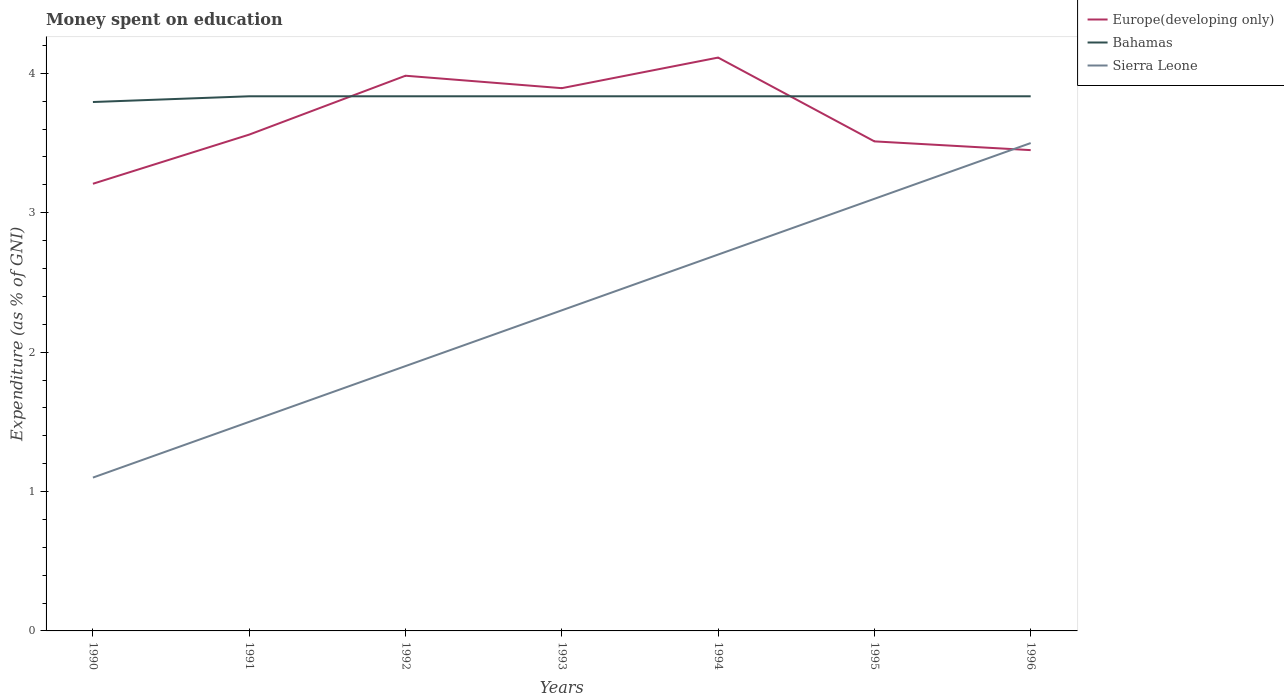How many different coloured lines are there?
Make the answer very short. 3. Across all years, what is the maximum amount of money spent on education in Europe(developing only)?
Your answer should be compact. 3.21. What is the total amount of money spent on education in Europe(developing only) in the graph?
Give a very brief answer. 0.44. What is the difference between the highest and the second highest amount of money spent on education in Sierra Leone?
Give a very brief answer. 2.4. How many lines are there?
Ensure brevity in your answer.  3. What is the difference between two consecutive major ticks on the Y-axis?
Offer a very short reply. 1. Does the graph contain any zero values?
Offer a very short reply. No. Does the graph contain grids?
Ensure brevity in your answer.  No. Where does the legend appear in the graph?
Give a very brief answer. Top right. How many legend labels are there?
Your answer should be very brief. 3. How are the legend labels stacked?
Your answer should be very brief. Vertical. What is the title of the graph?
Your response must be concise. Money spent on education. Does "Estonia" appear as one of the legend labels in the graph?
Keep it short and to the point. No. What is the label or title of the X-axis?
Give a very brief answer. Years. What is the label or title of the Y-axis?
Your answer should be very brief. Expenditure (as % of GNI). What is the Expenditure (as % of GNI) of Europe(developing only) in 1990?
Provide a succinct answer. 3.21. What is the Expenditure (as % of GNI) in Bahamas in 1990?
Give a very brief answer. 3.79. What is the Expenditure (as % of GNI) in Sierra Leone in 1990?
Provide a succinct answer. 1.1. What is the Expenditure (as % of GNI) in Europe(developing only) in 1991?
Make the answer very short. 3.56. What is the Expenditure (as % of GNI) of Bahamas in 1991?
Provide a short and direct response. 3.84. What is the Expenditure (as % of GNI) in Sierra Leone in 1991?
Offer a terse response. 1.5. What is the Expenditure (as % of GNI) in Europe(developing only) in 1992?
Offer a very short reply. 3.98. What is the Expenditure (as % of GNI) in Bahamas in 1992?
Provide a short and direct response. 3.84. What is the Expenditure (as % of GNI) of Sierra Leone in 1992?
Offer a very short reply. 1.9. What is the Expenditure (as % of GNI) of Europe(developing only) in 1993?
Offer a very short reply. 3.89. What is the Expenditure (as % of GNI) in Bahamas in 1993?
Ensure brevity in your answer.  3.84. What is the Expenditure (as % of GNI) of Sierra Leone in 1993?
Provide a succinct answer. 2.3. What is the Expenditure (as % of GNI) in Europe(developing only) in 1994?
Give a very brief answer. 4.11. What is the Expenditure (as % of GNI) in Bahamas in 1994?
Make the answer very short. 3.84. What is the Expenditure (as % of GNI) in Sierra Leone in 1994?
Your response must be concise. 2.7. What is the Expenditure (as % of GNI) of Europe(developing only) in 1995?
Ensure brevity in your answer.  3.51. What is the Expenditure (as % of GNI) in Bahamas in 1995?
Ensure brevity in your answer.  3.84. What is the Expenditure (as % of GNI) in Sierra Leone in 1995?
Give a very brief answer. 3.1. What is the Expenditure (as % of GNI) of Europe(developing only) in 1996?
Ensure brevity in your answer.  3.45. What is the Expenditure (as % of GNI) of Bahamas in 1996?
Ensure brevity in your answer.  3.84. What is the Expenditure (as % of GNI) of Sierra Leone in 1996?
Make the answer very short. 3.5. Across all years, what is the maximum Expenditure (as % of GNI) in Europe(developing only)?
Ensure brevity in your answer.  4.11. Across all years, what is the maximum Expenditure (as % of GNI) in Bahamas?
Provide a short and direct response. 3.84. Across all years, what is the maximum Expenditure (as % of GNI) of Sierra Leone?
Ensure brevity in your answer.  3.5. Across all years, what is the minimum Expenditure (as % of GNI) of Europe(developing only)?
Make the answer very short. 3.21. Across all years, what is the minimum Expenditure (as % of GNI) of Bahamas?
Offer a very short reply. 3.79. What is the total Expenditure (as % of GNI) in Europe(developing only) in the graph?
Ensure brevity in your answer.  25.72. What is the total Expenditure (as % of GNI) of Bahamas in the graph?
Ensure brevity in your answer.  26.81. What is the total Expenditure (as % of GNI) in Sierra Leone in the graph?
Your response must be concise. 16.1. What is the difference between the Expenditure (as % of GNI) of Europe(developing only) in 1990 and that in 1991?
Keep it short and to the point. -0.35. What is the difference between the Expenditure (as % of GNI) of Bahamas in 1990 and that in 1991?
Your response must be concise. -0.04. What is the difference between the Expenditure (as % of GNI) of Sierra Leone in 1990 and that in 1991?
Offer a terse response. -0.4. What is the difference between the Expenditure (as % of GNI) of Europe(developing only) in 1990 and that in 1992?
Offer a terse response. -0.78. What is the difference between the Expenditure (as % of GNI) in Bahamas in 1990 and that in 1992?
Offer a very short reply. -0.04. What is the difference between the Expenditure (as % of GNI) of Sierra Leone in 1990 and that in 1992?
Provide a short and direct response. -0.8. What is the difference between the Expenditure (as % of GNI) in Europe(developing only) in 1990 and that in 1993?
Your answer should be compact. -0.69. What is the difference between the Expenditure (as % of GNI) of Bahamas in 1990 and that in 1993?
Your answer should be compact. -0.04. What is the difference between the Expenditure (as % of GNI) in Sierra Leone in 1990 and that in 1993?
Keep it short and to the point. -1.2. What is the difference between the Expenditure (as % of GNI) of Europe(developing only) in 1990 and that in 1994?
Provide a short and direct response. -0.91. What is the difference between the Expenditure (as % of GNI) of Bahamas in 1990 and that in 1994?
Keep it short and to the point. -0.04. What is the difference between the Expenditure (as % of GNI) of Sierra Leone in 1990 and that in 1994?
Offer a terse response. -1.6. What is the difference between the Expenditure (as % of GNI) in Europe(developing only) in 1990 and that in 1995?
Make the answer very short. -0.3. What is the difference between the Expenditure (as % of GNI) of Bahamas in 1990 and that in 1995?
Make the answer very short. -0.04. What is the difference between the Expenditure (as % of GNI) in Europe(developing only) in 1990 and that in 1996?
Provide a short and direct response. -0.24. What is the difference between the Expenditure (as % of GNI) in Bahamas in 1990 and that in 1996?
Your answer should be very brief. -0.04. What is the difference between the Expenditure (as % of GNI) in Europe(developing only) in 1991 and that in 1992?
Make the answer very short. -0.42. What is the difference between the Expenditure (as % of GNI) in Bahamas in 1991 and that in 1992?
Provide a succinct answer. 0. What is the difference between the Expenditure (as % of GNI) of Sierra Leone in 1991 and that in 1992?
Your response must be concise. -0.4. What is the difference between the Expenditure (as % of GNI) in Europe(developing only) in 1991 and that in 1993?
Provide a short and direct response. -0.33. What is the difference between the Expenditure (as % of GNI) in Bahamas in 1991 and that in 1993?
Your answer should be very brief. 0. What is the difference between the Expenditure (as % of GNI) of Sierra Leone in 1991 and that in 1993?
Give a very brief answer. -0.8. What is the difference between the Expenditure (as % of GNI) of Europe(developing only) in 1991 and that in 1994?
Your answer should be very brief. -0.55. What is the difference between the Expenditure (as % of GNI) in Europe(developing only) in 1991 and that in 1995?
Provide a short and direct response. 0.05. What is the difference between the Expenditure (as % of GNI) of Bahamas in 1991 and that in 1995?
Provide a short and direct response. 0. What is the difference between the Expenditure (as % of GNI) in Europe(developing only) in 1991 and that in 1996?
Your response must be concise. 0.11. What is the difference between the Expenditure (as % of GNI) of Europe(developing only) in 1992 and that in 1993?
Provide a succinct answer. 0.09. What is the difference between the Expenditure (as % of GNI) of Bahamas in 1992 and that in 1993?
Provide a succinct answer. 0. What is the difference between the Expenditure (as % of GNI) in Europe(developing only) in 1992 and that in 1994?
Offer a terse response. -0.13. What is the difference between the Expenditure (as % of GNI) in Europe(developing only) in 1992 and that in 1995?
Offer a very short reply. 0.47. What is the difference between the Expenditure (as % of GNI) of Sierra Leone in 1992 and that in 1995?
Provide a short and direct response. -1.2. What is the difference between the Expenditure (as % of GNI) in Europe(developing only) in 1992 and that in 1996?
Make the answer very short. 0.53. What is the difference between the Expenditure (as % of GNI) of Sierra Leone in 1992 and that in 1996?
Your response must be concise. -1.6. What is the difference between the Expenditure (as % of GNI) of Europe(developing only) in 1993 and that in 1994?
Offer a terse response. -0.22. What is the difference between the Expenditure (as % of GNI) of Sierra Leone in 1993 and that in 1994?
Your answer should be very brief. -0.4. What is the difference between the Expenditure (as % of GNI) in Europe(developing only) in 1993 and that in 1995?
Your answer should be compact. 0.38. What is the difference between the Expenditure (as % of GNI) of Sierra Leone in 1993 and that in 1995?
Your answer should be compact. -0.8. What is the difference between the Expenditure (as % of GNI) of Europe(developing only) in 1993 and that in 1996?
Your answer should be very brief. 0.44. What is the difference between the Expenditure (as % of GNI) of Europe(developing only) in 1994 and that in 1995?
Your answer should be very brief. 0.6. What is the difference between the Expenditure (as % of GNI) in Sierra Leone in 1994 and that in 1995?
Ensure brevity in your answer.  -0.4. What is the difference between the Expenditure (as % of GNI) in Europe(developing only) in 1994 and that in 1996?
Your answer should be compact. 0.66. What is the difference between the Expenditure (as % of GNI) of Europe(developing only) in 1995 and that in 1996?
Offer a very short reply. 0.06. What is the difference between the Expenditure (as % of GNI) in Europe(developing only) in 1990 and the Expenditure (as % of GNI) in Bahamas in 1991?
Provide a succinct answer. -0.63. What is the difference between the Expenditure (as % of GNI) in Europe(developing only) in 1990 and the Expenditure (as % of GNI) in Sierra Leone in 1991?
Offer a very short reply. 1.71. What is the difference between the Expenditure (as % of GNI) of Bahamas in 1990 and the Expenditure (as % of GNI) of Sierra Leone in 1991?
Provide a succinct answer. 2.29. What is the difference between the Expenditure (as % of GNI) of Europe(developing only) in 1990 and the Expenditure (as % of GNI) of Bahamas in 1992?
Your response must be concise. -0.63. What is the difference between the Expenditure (as % of GNI) in Europe(developing only) in 1990 and the Expenditure (as % of GNI) in Sierra Leone in 1992?
Make the answer very short. 1.31. What is the difference between the Expenditure (as % of GNI) in Bahamas in 1990 and the Expenditure (as % of GNI) in Sierra Leone in 1992?
Your answer should be compact. 1.89. What is the difference between the Expenditure (as % of GNI) in Europe(developing only) in 1990 and the Expenditure (as % of GNI) in Bahamas in 1993?
Offer a terse response. -0.63. What is the difference between the Expenditure (as % of GNI) of Europe(developing only) in 1990 and the Expenditure (as % of GNI) of Sierra Leone in 1993?
Provide a short and direct response. 0.91. What is the difference between the Expenditure (as % of GNI) of Bahamas in 1990 and the Expenditure (as % of GNI) of Sierra Leone in 1993?
Offer a very short reply. 1.49. What is the difference between the Expenditure (as % of GNI) of Europe(developing only) in 1990 and the Expenditure (as % of GNI) of Bahamas in 1994?
Ensure brevity in your answer.  -0.63. What is the difference between the Expenditure (as % of GNI) in Europe(developing only) in 1990 and the Expenditure (as % of GNI) in Sierra Leone in 1994?
Provide a succinct answer. 0.51. What is the difference between the Expenditure (as % of GNI) of Bahamas in 1990 and the Expenditure (as % of GNI) of Sierra Leone in 1994?
Give a very brief answer. 1.09. What is the difference between the Expenditure (as % of GNI) of Europe(developing only) in 1990 and the Expenditure (as % of GNI) of Bahamas in 1995?
Make the answer very short. -0.63. What is the difference between the Expenditure (as % of GNI) in Europe(developing only) in 1990 and the Expenditure (as % of GNI) in Sierra Leone in 1995?
Offer a terse response. 0.11. What is the difference between the Expenditure (as % of GNI) in Bahamas in 1990 and the Expenditure (as % of GNI) in Sierra Leone in 1995?
Provide a succinct answer. 0.69. What is the difference between the Expenditure (as % of GNI) in Europe(developing only) in 1990 and the Expenditure (as % of GNI) in Bahamas in 1996?
Your answer should be compact. -0.63. What is the difference between the Expenditure (as % of GNI) of Europe(developing only) in 1990 and the Expenditure (as % of GNI) of Sierra Leone in 1996?
Your answer should be very brief. -0.29. What is the difference between the Expenditure (as % of GNI) in Bahamas in 1990 and the Expenditure (as % of GNI) in Sierra Leone in 1996?
Provide a short and direct response. 0.29. What is the difference between the Expenditure (as % of GNI) of Europe(developing only) in 1991 and the Expenditure (as % of GNI) of Bahamas in 1992?
Ensure brevity in your answer.  -0.28. What is the difference between the Expenditure (as % of GNI) in Europe(developing only) in 1991 and the Expenditure (as % of GNI) in Sierra Leone in 1992?
Offer a very short reply. 1.66. What is the difference between the Expenditure (as % of GNI) of Bahamas in 1991 and the Expenditure (as % of GNI) of Sierra Leone in 1992?
Your answer should be very brief. 1.94. What is the difference between the Expenditure (as % of GNI) in Europe(developing only) in 1991 and the Expenditure (as % of GNI) in Bahamas in 1993?
Give a very brief answer. -0.28. What is the difference between the Expenditure (as % of GNI) in Europe(developing only) in 1991 and the Expenditure (as % of GNI) in Sierra Leone in 1993?
Your answer should be compact. 1.26. What is the difference between the Expenditure (as % of GNI) in Bahamas in 1991 and the Expenditure (as % of GNI) in Sierra Leone in 1993?
Ensure brevity in your answer.  1.54. What is the difference between the Expenditure (as % of GNI) in Europe(developing only) in 1991 and the Expenditure (as % of GNI) in Bahamas in 1994?
Provide a short and direct response. -0.28. What is the difference between the Expenditure (as % of GNI) of Europe(developing only) in 1991 and the Expenditure (as % of GNI) of Sierra Leone in 1994?
Your answer should be very brief. 0.86. What is the difference between the Expenditure (as % of GNI) of Bahamas in 1991 and the Expenditure (as % of GNI) of Sierra Leone in 1994?
Keep it short and to the point. 1.14. What is the difference between the Expenditure (as % of GNI) of Europe(developing only) in 1991 and the Expenditure (as % of GNI) of Bahamas in 1995?
Provide a succinct answer. -0.28. What is the difference between the Expenditure (as % of GNI) of Europe(developing only) in 1991 and the Expenditure (as % of GNI) of Sierra Leone in 1995?
Your response must be concise. 0.46. What is the difference between the Expenditure (as % of GNI) in Bahamas in 1991 and the Expenditure (as % of GNI) in Sierra Leone in 1995?
Ensure brevity in your answer.  0.74. What is the difference between the Expenditure (as % of GNI) in Europe(developing only) in 1991 and the Expenditure (as % of GNI) in Bahamas in 1996?
Offer a very short reply. -0.28. What is the difference between the Expenditure (as % of GNI) in Europe(developing only) in 1991 and the Expenditure (as % of GNI) in Sierra Leone in 1996?
Ensure brevity in your answer.  0.06. What is the difference between the Expenditure (as % of GNI) of Bahamas in 1991 and the Expenditure (as % of GNI) of Sierra Leone in 1996?
Provide a short and direct response. 0.34. What is the difference between the Expenditure (as % of GNI) of Europe(developing only) in 1992 and the Expenditure (as % of GNI) of Bahamas in 1993?
Provide a succinct answer. 0.15. What is the difference between the Expenditure (as % of GNI) of Europe(developing only) in 1992 and the Expenditure (as % of GNI) of Sierra Leone in 1993?
Offer a very short reply. 1.68. What is the difference between the Expenditure (as % of GNI) of Bahamas in 1992 and the Expenditure (as % of GNI) of Sierra Leone in 1993?
Your answer should be compact. 1.54. What is the difference between the Expenditure (as % of GNI) of Europe(developing only) in 1992 and the Expenditure (as % of GNI) of Bahamas in 1994?
Provide a short and direct response. 0.15. What is the difference between the Expenditure (as % of GNI) of Europe(developing only) in 1992 and the Expenditure (as % of GNI) of Sierra Leone in 1994?
Offer a very short reply. 1.28. What is the difference between the Expenditure (as % of GNI) in Bahamas in 1992 and the Expenditure (as % of GNI) in Sierra Leone in 1994?
Give a very brief answer. 1.14. What is the difference between the Expenditure (as % of GNI) of Europe(developing only) in 1992 and the Expenditure (as % of GNI) of Bahamas in 1995?
Ensure brevity in your answer.  0.15. What is the difference between the Expenditure (as % of GNI) of Europe(developing only) in 1992 and the Expenditure (as % of GNI) of Sierra Leone in 1995?
Provide a succinct answer. 0.88. What is the difference between the Expenditure (as % of GNI) in Bahamas in 1992 and the Expenditure (as % of GNI) in Sierra Leone in 1995?
Provide a succinct answer. 0.74. What is the difference between the Expenditure (as % of GNI) of Europe(developing only) in 1992 and the Expenditure (as % of GNI) of Bahamas in 1996?
Provide a short and direct response. 0.15. What is the difference between the Expenditure (as % of GNI) of Europe(developing only) in 1992 and the Expenditure (as % of GNI) of Sierra Leone in 1996?
Provide a succinct answer. 0.48. What is the difference between the Expenditure (as % of GNI) in Bahamas in 1992 and the Expenditure (as % of GNI) in Sierra Leone in 1996?
Offer a very short reply. 0.34. What is the difference between the Expenditure (as % of GNI) of Europe(developing only) in 1993 and the Expenditure (as % of GNI) of Bahamas in 1994?
Give a very brief answer. 0.06. What is the difference between the Expenditure (as % of GNI) of Europe(developing only) in 1993 and the Expenditure (as % of GNI) of Sierra Leone in 1994?
Provide a succinct answer. 1.19. What is the difference between the Expenditure (as % of GNI) of Bahamas in 1993 and the Expenditure (as % of GNI) of Sierra Leone in 1994?
Make the answer very short. 1.14. What is the difference between the Expenditure (as % of GNI) of Europe(developing only) in 1993 and the Expenditure (as % of GNI) of Bahamas in 1995?
Provide a short and direct response. 0.06. What is the difference between the Expenditure (as % of GNI) in Europe(developing only) in 1993 and the Expenditure (as % of GNI) in Sierra Leone in 1995?
Offer a terse response. 0.79. What is the difference between the Expenditure (as % of GNI) of Bahamas in 1993 and the Expenditure (as % of GNI) of Sierra Leone in 1995?
Make the answer very short. 0.74. What is the difference between the Expenditure (as % of GNI) of Europe(developing only) in 1993 and the Expenditure (as % of GNI) of Bahamas in 1996?
Keep it short and to the point. 0.06. What is the difference between the Expenditure (as % of GNI) in Europe(developing only) in 1993 and the Expenditure (as % of GNI) in Sierra Leone in 1996?
Make the answer very short. 0.39. What is the difference between the Expenditure (as % of GNI) of Bahamas in 1993 and the Expenditure (as % of GNI) of Sierra Leone in 1996?
Offer a terse response. 0.34. What is the difference between the Expenditure (as % of GNI) of Europe(developing only) in 1994 and the Expenditure (as % of GNI) of Bahamas in 1995?
Ensure brevity in your answer.  0.28. What is the difference between the Expenditure (as % of GNI) in Europe(developing only) in 1994 and the Expenditure (as % of GNI) in Sierra Leone in 1995?
Ensure brevity in your answer.  1.01. What is the difference between the Expenditure (as % of GNI) in Bahamas in 1994 and the Expenditure (as % of GNI) in Sierra Leone in 1995?
Your response must be concise. 0.74. What is the difference between the Expenditure (as % of GNI) of Europe(developing only) in 1994 and the Expenditure (as % of GNI) of Bahamas in 1996?
Your answer should be compact. 0.28. What is the difference between the Expenditure (as % of GNI) of Europe(developing only) in 1994 and the Expenditure (as % of GNI) of Sierra Leone in 1996?
Your answer should be very brief. 0.61. What is the difference between the Expenditure (as % of GNI) in Bahamas in 1994 and the Expenditure (as % of GNI) in Sierra Leone in 1996?
Provide a short and direct response. 0.34. What is the difference between the Expenditure (as % of GNI) of Europe(developing only) in 1995 and the Expenditure (as % of GNI) of Bahamas in 1996?
Make the answer very short. -0.32. What is the difference between the Expenditure (as % of GNI) in Europe(developing only) in 1995 and the Expenditure (as % of GNI) in Sierra Leone in 1996?
Your answer should be very brief. 0.01. What is the difference between the Expenditure (as % of GNI) in Bahamas in 1995 and the Expenditure (as % of GNI) in Sierra Leone in 1996?
Provide a short and direct response. 0.34. What is the average Expenditure (as % of GNI) of Europe(developing only) per year?
Give a very brief answer. 3.67. What is the average Expenditure (as % of GNI) of Bahamas per year?
Your answer should be very brief. 3.83. In the year 1990, what is the difference between the Expenditure (as % of GNI) in Europe(developing only) and Expenditure (as % of GNI) in Bahamas?
Offer a terse response. -0.59. In the year 1990, what is the difference between the Expenditure (as % of GNI) in Europe(developing only) and Expenditure (as % of GNI) in Sierra Leone?
Keep it short and to the point. 2.11. In the year 1990, what is the difference between the Expenditure (as % of GNI) in Bahamas and Expenditure (as % of GNI) in Sierra Leone?
Offer a terse response. 2.69. In the year 1991, what is the difference between the Expenditure (as % of GNI) of Europe(developing only) and Expenditure (as % of GNI) of Bahamas?
Provide a short and direct response. -0.28. In the year 1991, what is the difference between the Expenditure (as % of GNI) of Europe(developing only) and Expenditure (as % of GNI) of Sierra Leone?
Your response must be concise. 2.06. In the year 1991, what is the difference between the Expenditure (as % of GNI) in Bahamas and Expenditure (as % of GNI) in Sierra Leone?
Offer a very short reply. 2.34. In the year 1992, what is the difference between the Expenditure (as % of GNI) of Europe(developing only) and Expenditure (as % of GNI) of Bahamas?
Your answer should be compact. 0.15. In the year 1992, what is the difference between the Expenditure (as % of GNI) of Europe(developing only) and Expenditure (as % of GNI) of Sierra Leone?
Provide a succinct answer. 2.08. In the year 1992, what is the difference between the Expenditure (as % of GNI) in Bahamas and Expenditure (as % of GNI) in Sierra Leone?
Provide a succinct answer. 1.94. In the year 1993, what is the difference between the Expenditure (as % of GNI) in Europe(developing only) and Expenditure (as % of GNI) in Bahamas?
Your answer should be very brief. 0.06. In the year 1993, what is the difference between the Expenditure (as % of GNI) of Europe(developing only) and Expenditure (as % of GNI) of Sierra Leone?
Offer a very short reply. 1.59. In the year 1993, what is the difference between the Expenditure (as % of GNI) in Bahamas and Expenditure (as % of GNI) in Sierra Leone?
Your response must be concise. 1.54. In the year 1994, what is the difference between the Expenditure (as % of GNI) in Europe(developing only) and Expenditure (as % of GNI) in Bahamas?
Your response must be concise. 0.28. In the year 1994, what is the difference between the Expenditure (as % of GNI) in Europe(developing only) and Expenditure (as % of GNI) in Sierra Leone?
Ensure brevity in your answer.  1.41. In the year 1994, what is the difference between the Expenditure (as % of GNI) of Bahamas and Expenditure (as % of GNI) of Sierra Leone?
Provide a short and direct response. 1.14. In the year 1995, what is the difference between the Expenditure (as % of GNI) in Europe(developing only) and Expenditure (as % of GNI) in Bahamas?
Your response must be concise. -0.32. In the year 1995, what is the difference between the Expenditure (as % of GNI) in Europe(developing only) and Expenditure (as % of GNI) in Sierra Leone?
Offer a terse response. 0.41. In the year 1995, what is the difference between the Expenditure (as % of GNI) in Bahamas and Expenditure (as % of GNI) in Sierra Leone?
Offer a terse response. 0.74. In the year 1996, what is the difference between the Expenditure (as % of GNI) of Europe(developing only) and Expenditure (as % of GNI) of Bahamas?
Ensure brevity in your answer.  -0.39. In the year 1996, what is the difference between the Expenditure (as % of GNI) of Europe(developing only) and Expenditure (as % of GNI) of Sierra Leone?
Offer a very short reply. -0.05. In the year 1996, what is the difference between the Expenditure (as % of GNI) in Bahamas and Expenditure (as % of GNI) in Sierra Leone?
Provide a short and direct response. 0.34. What is the ratio of the Expenditure (as % of GNI) of Europe(developing only) in 1990 to that in 1991?
Keep it short and to the point. 0.9. What is the ratio of the Expenditure (as % of GNI) in Bahamas in 1990 to that in 1991?
Offer a terse response. 0.99. What is the ratio of the Expenditure (as % of GNI) of Sierra Leone in 1990 to that in 1991?
Provide a succinct answer. 0.73. What is the ratio of the Expenditure (as % of GNI) in Europe(developing only) in 1990 to that in 1992?
Offer a terse response. 0.81. What is the ratio of the Expenditure (as % of GNI) of Bahamas in 1990 to that in 1992?
Give a very brief answer. 0.99. What is the ratio of the Expenditure (as % of GNI) of Sierra Leone in 1990 to that in 1992?
Your answer should be very brief. 0.58. What is the ratio of the Expenditure (as % of GNI) of Europe(developing only) in 1990 to that in 1993?
Offer a very short reply. 0.82. What is the ratio of the Expenditure (as % of GNI) in Bahamas in 1990 to that in 1993?
Provide a succinct answer. 0.99. What is the ratio of the Expenditure (as % of GNI) of Sierra Leone in 1990 to that in 1993?
Offer a very short reply. 0.48. What is the ratio of the Expenditure (as % of GNI) of Europe(developing only) in 1990 to that in 1994?
Offer a very short reply. 0.78. What is the ratio of the Expenditure (as % of GNI) in Bahamas in 1990 to that in 1994?
Your answer should be very brief. 0.99. What is the ratio of the Expenditure (as % of GNI) in Sierra Leone in 1990 to that in 1994?
Provide a short and direct response. 0.41. What is the ratio of the Expenditure (as % of GNI) of Europe(developing only) in 1990 to that in 1995?
Offer a terse response. 0.91. What is the ratio of the Expenditure (as % of GNI) of Bahamas in 1990 to that in 1995?
Offer a very short reply. 0.99. What is the ratio of the Expenditure (as % of GNI) in Sierra Leone in 1990 to that in 1995?
Your response must be concise. 0.35. What is the ratio of the Expenditure (as % of GNI) in Europe(developing only) in 1990 to that in 1996?
Your answer should be very brief. 0.93. What is the ratio of the Expenditure (as % of GNI) of Bahamas in 1990 to that in 1996?
Provide a short and direct response. 0.99. What is the ratio of the Expenditure (as % of GNI) of Sierra Leone in 1990 to that in 1996?
Offer a terse response. 0.31. What is the ratio of the Expenditure (as % of GNI) of Europe(developing only) in 1991 to that in 1992?
Offer a very short reply. 0.89. What is the ratio of the Expenditure (as % of GNI) of Sierra Leone in 1991 to that in 1992?
Make the answer very short. 0.79. What is the ratio of the Expenditure (as % of GNI) in Europe(developing only) in 1991 to that in 1993?
Make the answer very short. 0.91. What is the ratio of the Expenditure (as % of GNI) of Bahamas in 1991 to that in 1993?
Offer a very short reply. 1. What is the ratio of the Expenditure (as % of GNI) in Sierra Leone in 1991 to that in 1993?
Your answer should be very brief. 0.65. What is the ratio of the Expenditure (as % of GNI) of Europe(developing only) in 1991 to that in 1994?
Provide a succinct answer. 0.87. What is the ratio of the Expenditure (as % of GNI) in Sierra Leone in 1991 to that in 1994?
Provide a succinct answer. 0.56. What is the ratio of the Expenditure (as % of GNI) in Europe(developing only) in 1991 to that in 1995?
Offer a very short reply. 1.01. What is the ratio of the Expenditure (as % of GNI) of Sierra Leone in 1991 to that in 1995?
Provide a short and direct response. 0.48. What is the ratio of the Expenditure (as % of GNI) of Europe(developing only) in 1991 to that in 1996?
Keep it short and to the point. 1.03. What is the ratio of the Expenditure (as % of GNI) of Sierra Leone in 1991 to that in 1996?
Give a very brief answer. 0.43. What is the ratio of the Expenditure (as % of GNI) in Europe(developing only) in 1992 to that in 1993?
Give a very brief answer. 1.02. What is the ratio of the Expenditure (as % of GNI) of Bahamas in 1992 to that in 1993?
Offer a very short reply. 1. What is the ratio of the Expenditure (as % of GNI) in Sierra Leone in 1992 to that in 1993?
Ensure brevity in your answer.  0.83. What is the ratio of the Expenditure (as % of GNI) in Europe(developing only) in 1992 to that in 1994?
Give a very brief answer. 0.97. What is the ratio of the Expenditure (as % of GNI) of Bahamas in 1992 to that in 1994?
Keep it short and to the point. 1. What is the ratio of the Expenditure (as % of GNI) in Sierra Leone in 1992 to that in 1994?
Ensure brevity in your answer.  0.7. What is the ratio of the Expenditure (as % of GNI) of Europe(developing only) in 1992 to that in 1995?
Offer a very short reply. 1.13. What is the ratio of the Expenditure (as % of GNI) of Sierra Leone in 1992 to that in 1995?
Provide a succinct answer. 0.61. What is the ratio of the Expenditure (as % of GNI) of Europe(developing only) in 1992 to that in 1996?
Your answer should be compact. 1.15. What is the ratio of the Expenditure (as % of GNI) in Sierra Leone in 1992 to that in 1996?
Offer a terse response. 0.54. What is the ratio of the Expenditure (as % of GNI) in Europe(developing only) in 1993 to that in 1994?
Your answer should be very brief. 0.95. What is the ratio of the Expenditure (as % of GNI) in Bahamas in 1993 to that in 1994?
Ensure brevity in your answer.  1. What is the ratio of the Expenditure (as % of GNI) of Sierra Leone in 1993 to that in 1994?
Ensure brevity in your answer.  0.85. What is the ratio of the Expenditure (as % of GNI) of Europe(developing only) in 1993 to that in 1995?
Your response must be concise. 1.11. What is the ratio of the Expenditure (as % of GNI) in Bahamas in 1993 to that in 1995?
Ensure brevity in your answer.  1. What is the ratio of the Expenditure (as % of GNI) in Sierra Leone in 1993 to that in 1995?
Give a very brief answer. 0.74. What is the ratio of the Expenditure (as % of GNI) of Europe(developing only) in 1993 to that in 1996?
Ensure brevity in your answer.  1.13. What is the ratio of the Expenditure (as % of GNI) of Bahamas in 1993 to that in 1996?
Provide a succinct answer. 1. What is the ratio of the Expenditure (as % of GNI) of Sierra Leone in 1993 to that in 1996?
Provide a succinct answer. 0.66. What is the ratio of the Expenditure (as % of GNI) of Europe(developing only) in 1994 to that in 1995?
Provide a succinct answer. 1.17. What is the ratio of the Expenditure (as % of GNI) in Bahamas in 1994 to that in 1995?
Give a very brief answer. 1. What is the ratio of the Expenditure (as % of GNI) in Sierra Leone in 1994 to that in 1995?
Keep it short and to the point. 0.87. What is the ratio of the Expenditure (as % of GNI) of Europe(developing only) in 1994 to that in 1996?
Provide a short and direct response. 1.19. What is the ratio of the Expenditure (as % of GNI) of Sierra Leone in 1994 to that in 1996?
Your answer should be very brief. 0.77. What is the ratio of the Expenditure (as % of GNI) in Europe(developing only) in 1995 to that in 1996?
Make the answer very short. 1.02. What is the ratio of the Expenditure (as % of GNI) of Bahamas in 1995 to that in 1996?
Keep it short and to the point. 1. What is the ratio of the Expenditure (as % of GNI) in Sierra Leone in 1995 to that in 1996?
Offer a terse response. 0.89. What is the difference between the highest and the second highest Expenditure (as % of GNI) in Europe(developing only)?
Offer a very short reply. 0.13. What is the difference between the highest and the lowest Expenditure (as % of GNI) of Europe(developing only)?
Make the answer very short. 0.91. What is the difference between the highest and the lowest Expenditure (as % of GNI) of Bahamas?
Ensure brevity in your answer.  0.04. 